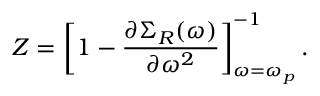<formula> <loc_0><loc_0><loc_500><loc_500>Z = \left [ 1 - \frac { \partial \Sigma _ { R } ( \omega ) } { \partial \omega ^ { 2 } } \right ] _ { \omega = \omega _ { p } } ^ { - 1 } .</formula> 